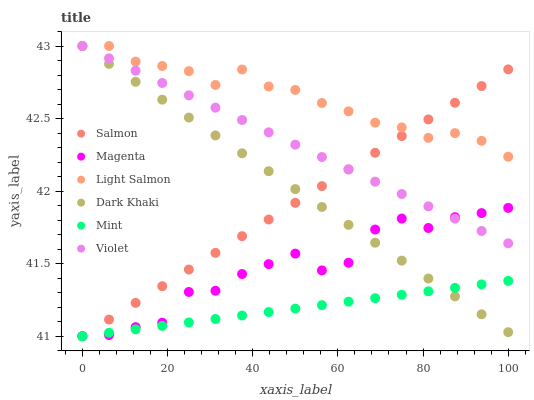Does Mint have the minimum area under the curve?
Answer yes or no. Yes. Does Light Salmon have the maximum area under the curve?
Answer yes or no. Yes. Does Salmon have the minimum area under the curve?
Answer yes or no. No. Does Salmon have the maximum area under the curve?
Answer yes or no. No. Is Violet the smoothest?
Answer yes or no. Yes. Is Magenta the roughest?
Answer yes or no. Yes. Is Salmon the smoothest?
Answer yes or no. No. Is Salmon the roughest?
Answer yes or no. No. Does Salmon have the lowest value?
Answer yes or no. Yes. Does Dark Khaki have the lowest value?
Answer yes or no. No. Does Violet have the highest value?
Answer yes or no. Yes. Does Salmon have the highest value?
Answer yes or no. No. Is Mint less than Light Salmon?
Answer yes or no. Yes. Is Light Salmon greater than Mint?
Answer yes or no. Yes. Does Violet intersect Dark Khaki?
Answer yes or no. Yes. Is Violet less than Dark Khaki?
Answer yes or no. No. Is Violet greater than Dark Khaki?
Answer yes or no. No. Does Mint intersect Light Salmon?
Answer yes or no. No. 